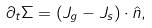Convert formula to latex. <formula><loc_0><loc_0><loc_500><loc_500>\partial _ { t } \Sigma = \left ( { J } _ { g } - { J } _ { s } \right ) \cdot \hat { n } ,</formula> 